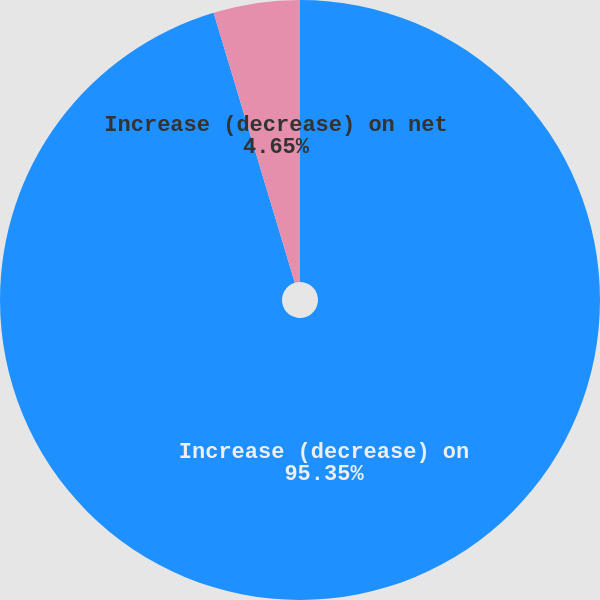<chart> <loc_0><loc_0><loc_500><loc_500><pie_chart><fcel>Increase (decrease) on<fcel>Increase (decrease) on net<nl><fcel>95.35%<fcel>4.65%<nl></chart> 